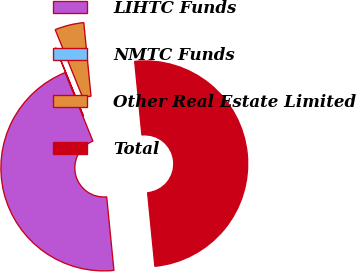<chart> <loc_0><loc_0><loc_500><loc_500><pie_chart><fcel>LIHTC Funds<fcel>NMTC Funds<fcel>Other Real Estate Limited<fcel>Total<nl><fcel>45.43%<fcel>0.01%<fcel>4.57%<fcel>49.99%<nl></chart> 